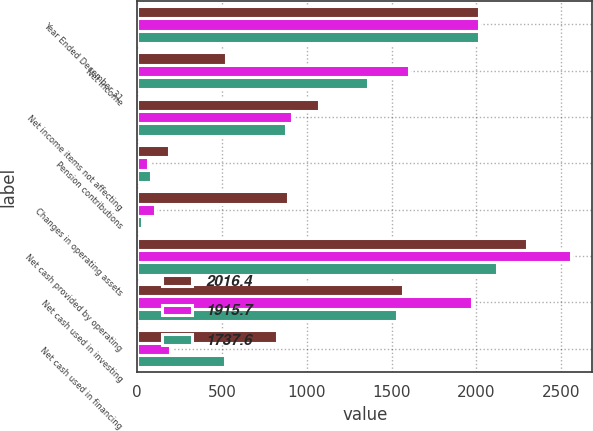<chart> <loc_0><loc_0><loc_500><loc_500><stacked_bar_chart><ecel><fcel>Year Ended December 31<fcel>Net income<fcel>Net income items not affecting<fcel>Pension contributions<fcel>Changes in operating assets<fcel>Net cash provided by operating<fcel>Net cash used in investing<fcel>Net cash used in financing<nl><fcel>2016.4<fcel>2016<fcel>521.7<fcel>1072.7<fcel>185.7<fcel>892.1<fcel>2300.8<fcel>1564.3<fcel>823.5<nl><fcel>1915.7<fcel>2015<fcel>1604<fcel>910.9<fcel>62.9<fcel>104<fcel>2556<fcel>1974.9<fcel>196.5<nl><fcel>1737.6<fcel>2014<fcel>1358.8<fcel>875.5<fcel>81.1<fcel>29.6<fcel>2123.6<fcel>1531.9<fcel>520.5<nl></chart> 